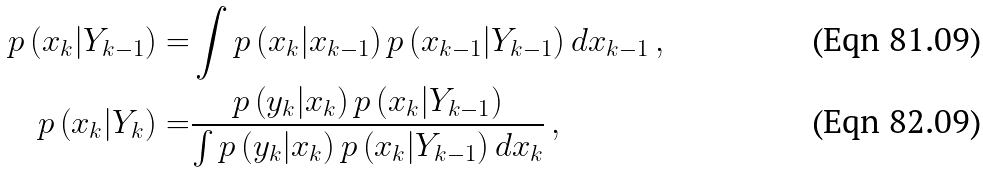Convert formula to latex. <formula><loc_0><loc_0><loc_500><loc_500>p \left ( x _ { k } | Y _ { k - 1 } \right ) = & \int p \left ( x _ { k } | x _ { k - 1 } \right ) p \left ( x _ { k - 1 } | Y _ { k - 1 } \right ) d x _ { k - 1 } \, , \\ p \left ( x _ { k } | Y _ { k } \right ) = & \frac { p \left ( y _ { k } | x _ { k } \right ) p \left ( x _ { k } | Y _ { k - 1 } \right ) } { \int p \left ( y _ { k } | x _ { k } \right ) p \left ( x _ { k } | Y _ { k - 1 } \right ) d x _ { k } } \, ,</formula> 